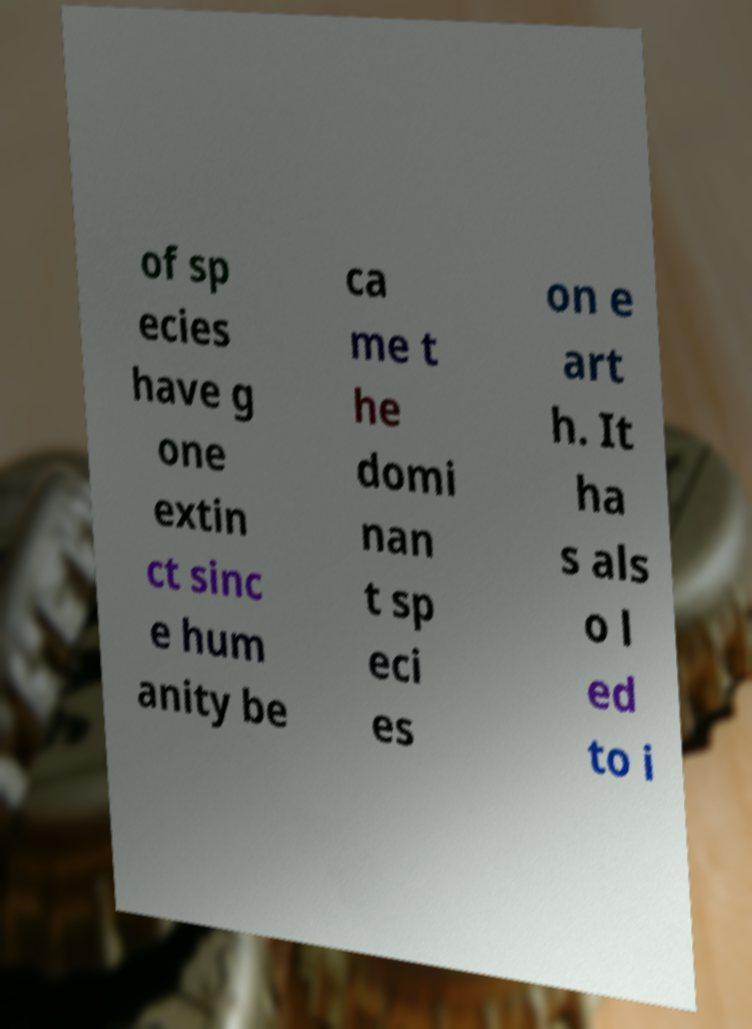Could you extract and type out the text from this image? of sp ecies have g one extin ct sinc e hum anity be ca me t he domi nan t sp eci es on e art h. It ha s als o l ed to i 